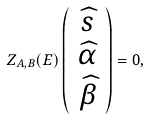<formula> <loc_0><loc_0><loc_500><loc_500>Z _ { A , B } ( E ) \left ( \begin{array} { c } \widehat { s } \\ \widehat { \alpha } \\ \widehat { \beta } \end{array} \right ) = 0 ,</formula> 